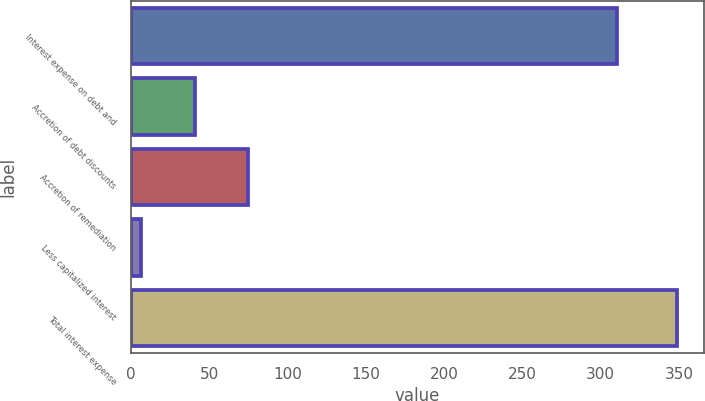Convert chart. <chart><loc_0><loc_0><loc_500><loc_500><bar_chart><fcel>Interest expense on debt and<fcel>Accretion of debt discounts<fcel>Accretion of remediation<fcel>Less capitalized interest<fcel>Total interest expense<nl><fcel>310.3<fcel>40.63<fcel>74.86<fcel>6.4<fcel>348.7<nl></chart> 